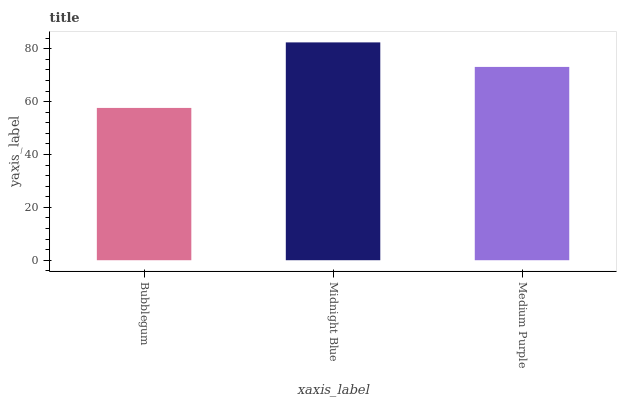Is Bubblegum the minimum?
Answer yes or no. Yes. Is Midnight Blue the maximum?
Answer yes or no. Yes. Is Medium Purple the minimum?
Answer yes or no. No. Is Medium Purple the maximum?
Answer yes or no. No. Is Midnight Blue greater than Medium Purple?
Answer yes or no. Yes. Is Medium Purple less than Midnight Blue?
Answer yes or no. Yes. Is Medium Purple greater than Midnight Blue?
Answer yes or no. No. Is Midnight Blue less than Medium Purple?
Answer yes or no. No. Is Medium Purple the high median?
Answer yes or no. Yes. Is Medium Purple the low median?
Answer yes or no. Yes. Is Midnight Blue the high median?
Answer yes or no. No. Is Midnight Blue the low median?
Answer yes or no. No. 